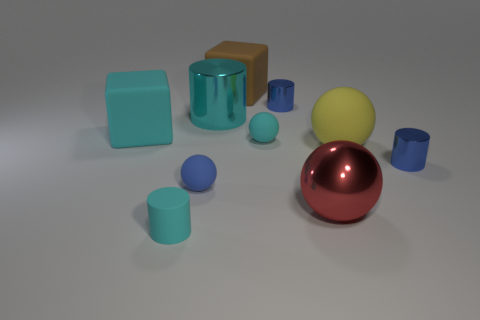Subtract all gray cylinders. Subtract all purple cubes. How many cylinders are left? 4 Subtract all spheres. How many objects are left? 6 Subtract all large metal cylinders. Subtract all big red objects. How many objects are left? 8 Add 2 cyan cubes. How many cyan cubes are left? 3 Add 10 green shiny objects. How many green shiny objects exist? 10 Subtract 1 yellow balls. How many objects are left? 9 